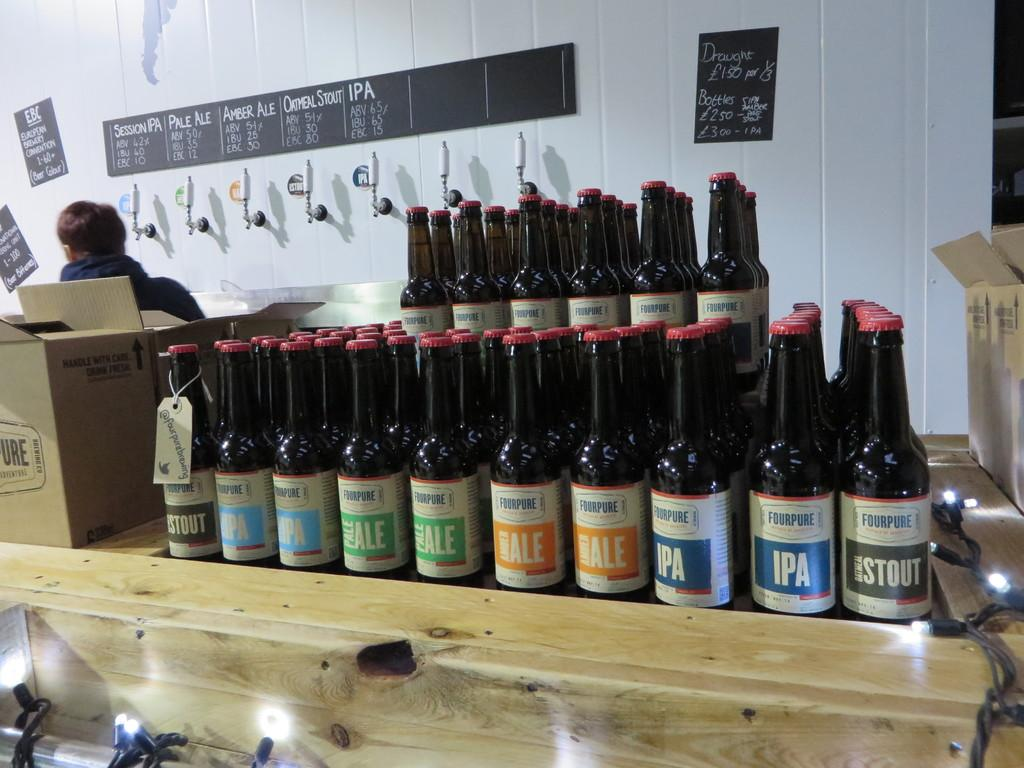What objects are visible in the image that have labels? There are bottles with labels in the image. Where are the bottles placed? The bottles are placed on a table. What can be seen in the background of the image? There are boxes and a person standing near a wall in the background of the image. What type of pleasure can be seen in the image? There is no indication of pleasure in the image; it primarily features bottles with labels and other objects. 